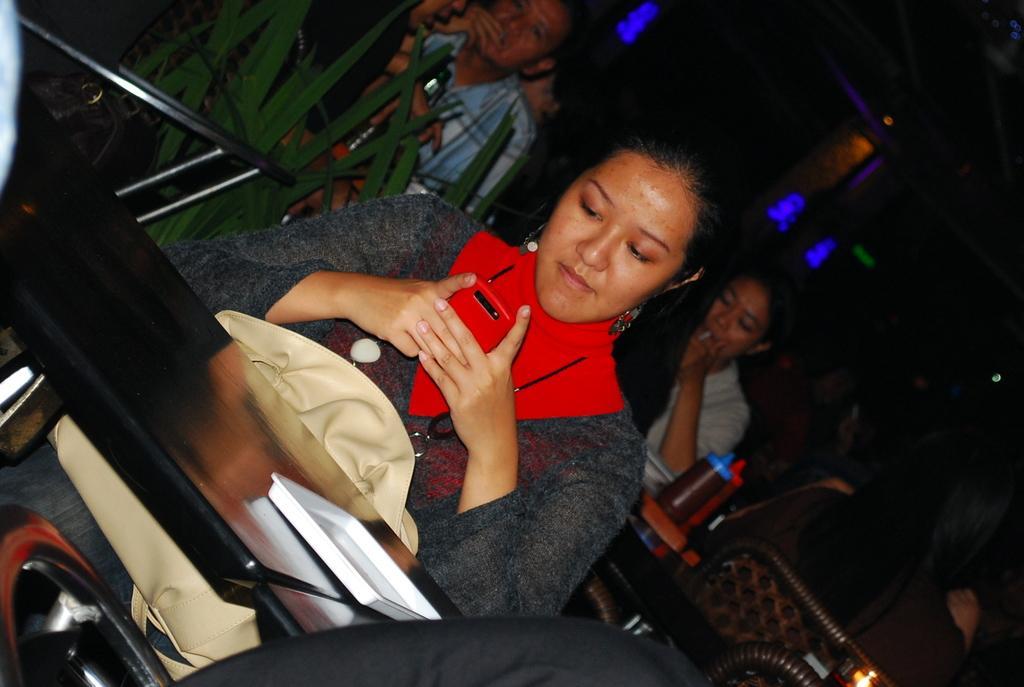How would you summarize this image in a sentence or two? In this image we can see a woman holding the mobile phone and sitting in front of the table with a bag and on the table we can see the white color plate. In the background, we can see the plant and also the people sitting on the chairs in front of the dining table and on the table we can see the sauce bottles. We can also see the sights. 